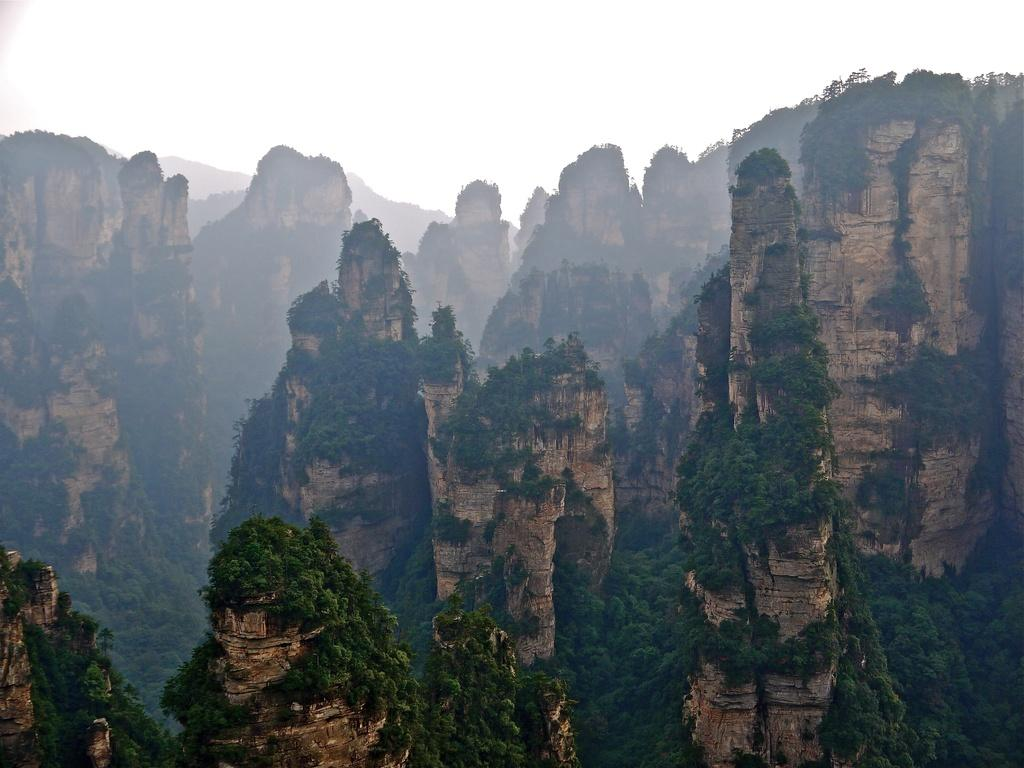What geographical feature is visible in the image? There are mountains in the image. What is covering the mountains in the image? The mountains are covered with trees. Where is the group meeting in the image? There is no group or meeting present in the image; it only features mountains covered with trees. 